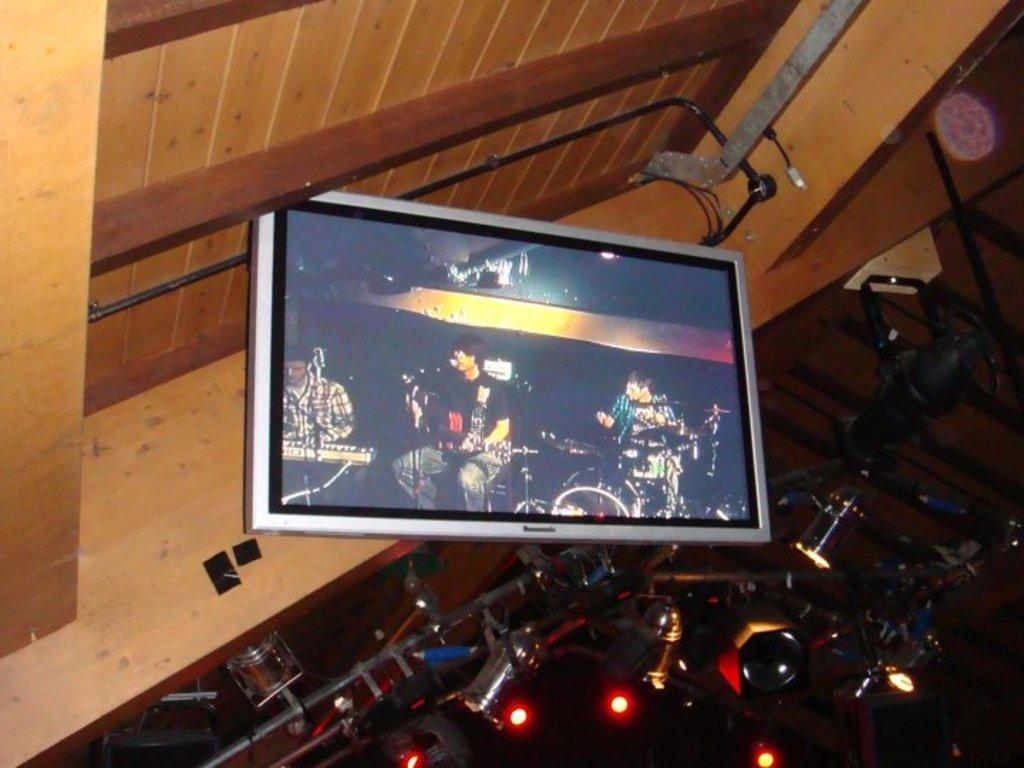What type of objects can be seen in the image? There are lights, rods, a screen, and a roof in the image. What is happening on the screen in the image? People are playing musical instruments on the screen. What equipment is being used by the people playing musical instruments? There are microphones in front of the people playing musical instruments. What type of vase is present on the roof in the image? There is no vase present in the image; the roof is a part of a structure and does not contain any vases. 